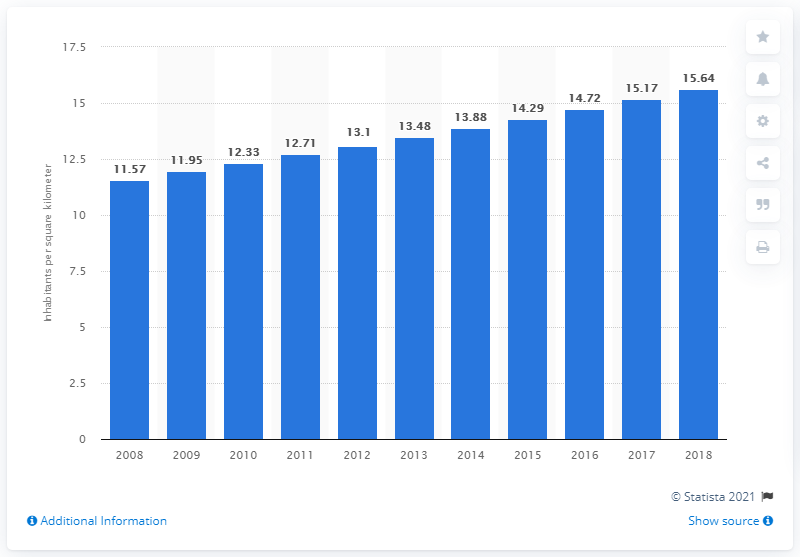Draw attention to some important aspects in this diagram. In 2018, the population density in Mali was 15.64 people per square kilometer. 